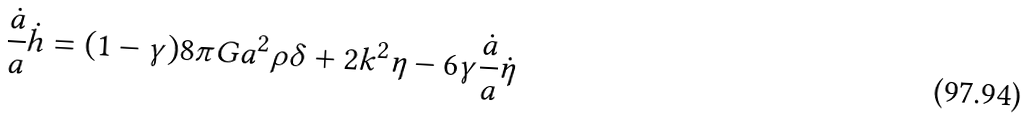Convert formula to latex. <formula><loc_0><loc_0><loc_500><loc_500>\frac { \dot { a } } { a } \dot { h } = ( 1 - \gamma ) 8 \pi G a ^ { 2 } \rho \delta + 2 k ^ { 2 } \eta - 6 \gamma \frac { \dot { a } } { a } \dot { \eta }</formula> 